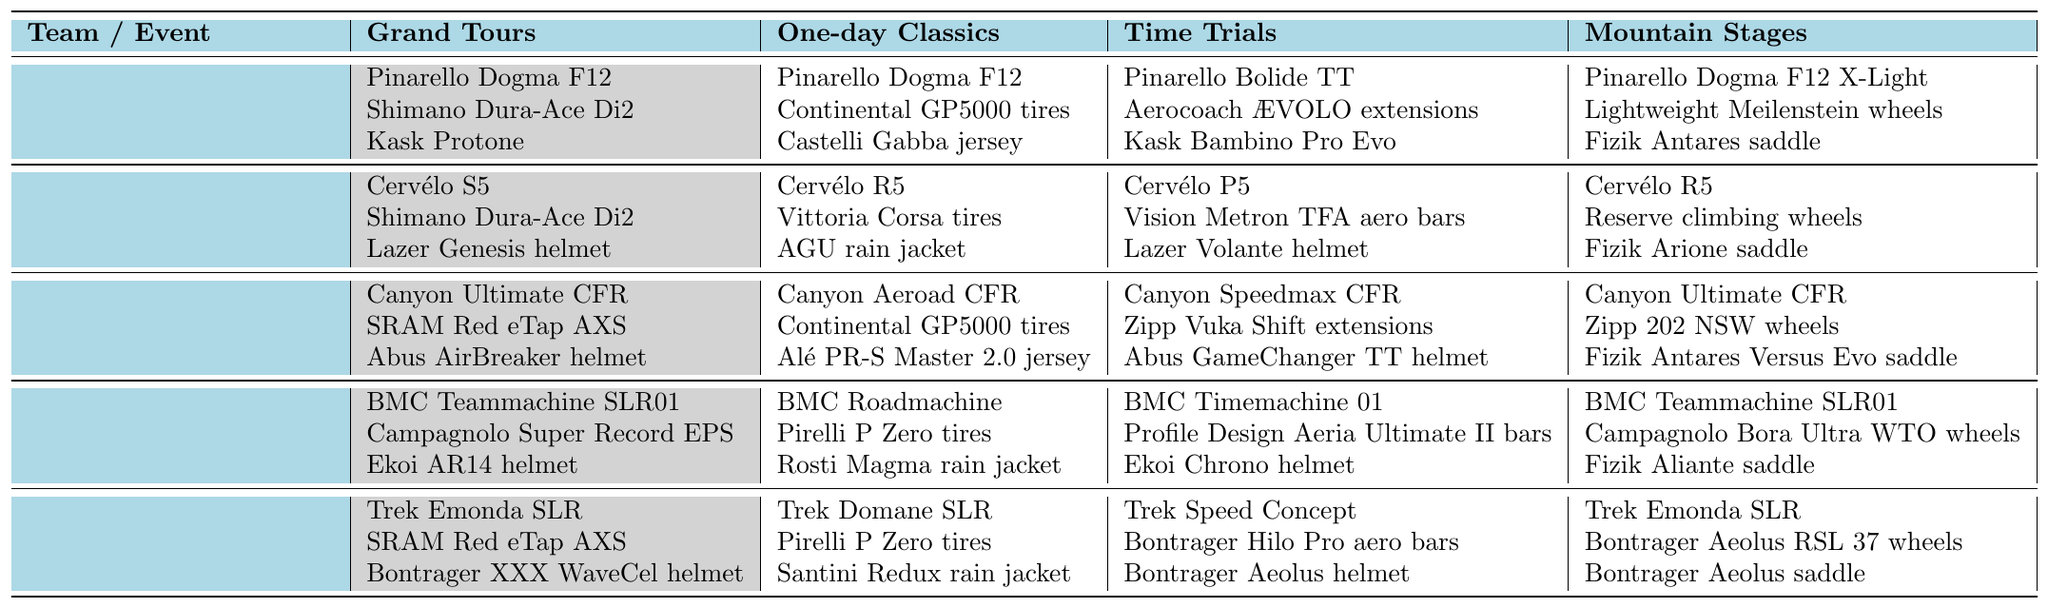What cycling equipment is preferred by Team Ineos Grenadiers for Time Trials? In the table, under the row for Team Ineos Grenadiers and the column for Time Trials, the preferred equipment includes: Pinarello Bolide TT, Aerocoach ÆVOLO extensions, and Kask Bambino Pro Evo.
Answer: Pinarello Bolide TT, Aerocoach ÆVOLO extensions, Kask Bambino Pro Evo Which team prefers the Cervélo R5 for One-day Classics? Looking through the table, Cervélo R5 is listed under the One-day Classics column for Jumbo-Visma.
Answer: Jumbo-Visma How many different types of equipment does Team Movistar use in Grand Tours compared to Time Trials? Team Movistar lists 3 different types of equipment for Grand Tours and the same number for Time Trials (Canyon Ultimate CFR, SRAM Red eTap AXS, and Abus AirBreaker helmet; Canyon Speedmax CFR, Zipp Vuka Shift extensions, and Abus GameChanger TT helmet). Therefore, both have 3 types, showing no difference in quantity.
Answer: 0 Is the Pinarello Dogma F12 used in any other events besides Grand Tours by Team Ineos Grenadiers? By checking the table, the Pinarello Dogma F12 is used in both Grand Tours and One-day Classics by Team Ineos Grenadiers.
Answer: Yes What is the unique helmet used by Jumbo-Visma in Time Trials? In the Time Trials column for Jumbo-Visma, the unique helmet mentioned is Lazer Volante helmet.
Answer: Lazer Volante helmet Which team has the same model bike for both Grand Tours and Mountain Stages? A review of the table shows that Team Movistar has Canyon Ultimate CFR listed under both Grand Tours and Mountain Stages, indicating the same model bike is used in both events.
Answer: Movistar Team What is the average number of tire brands used by the teams in One-day Classics? For One-day Classics, the tire brands used are Continental GP5000 tires by Team Ineos and Movistar, Vittoria Corsa tires by Jumbo-Visma, and Pirelli P Zero tires by AG2R Citroën and Trek-Segafredo. There are 5 tire brands across 5 teams, thus the average is 5/5 = 1.
Answer: 1 What is the preferred equipment for Time Trials across all teams? The preferred equipment for Time Trials includes Pinarello Bolide TT (Team Ineos), Cervélo P5 (Jumbo-Visma), Canyon Speedmax CFR (Movistar), BMC Timemachine 01 (AG2R Citroën), and Trek Speed Concept (Trek-Segafredo).
Answer: Various: Pinarello Bolide TT, Cervélo P5, Canyon Speedmax CFR, BMC Timemachine 01, Trek Speed Concept Which team uses the Bontrager XXX WaveCel helmet in Grand Tours? The table indicates that the Bontrager XXX WaveCel helmet is used by Trek-Segafredo in Grand Tours.
Answer: Trek-Segafredo Are there any teams that use SRAM Red eTap AXS in both Grand Tours and Mountain Stages? By examining the table, it shows that Team Movistar uses SRAM Red eTap AXS in Grand Tours and Team Trek-Segafredo uses SRAM Red eTap AXS in Mountain Stages; hence, both teams use it in either event but not the same team for both.
Answer: No 